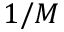<formula> <loc_0><loc_0><loc_500><loc_500>1 / M</formula> 